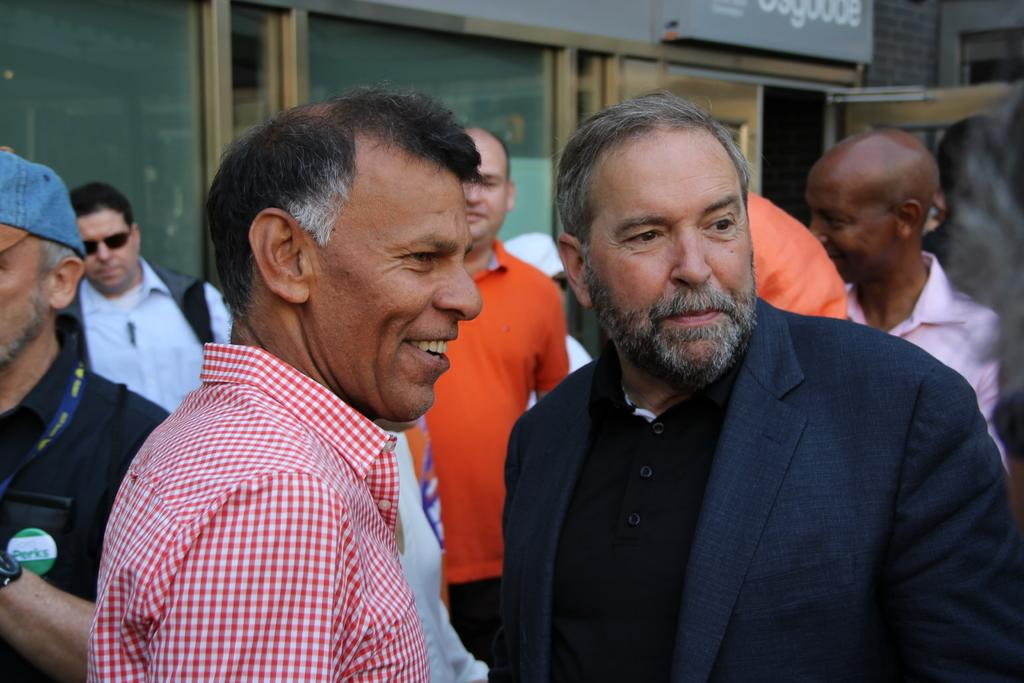What is happening in the center of the image? There are people standing in the center of the image. What can be seen in the background of the image? There is a building in the background of the image. What type of yam is being used as a prop in the image? There is no yam present in the image. What kind of system is being demonstrated by the people in the image? The image does not show any system being demonstrated by the people. 